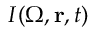<formula> <loc_0><loc_0><loc_500><loc_500>I ( { \Omega } , \mathbf r , t )</formula> 